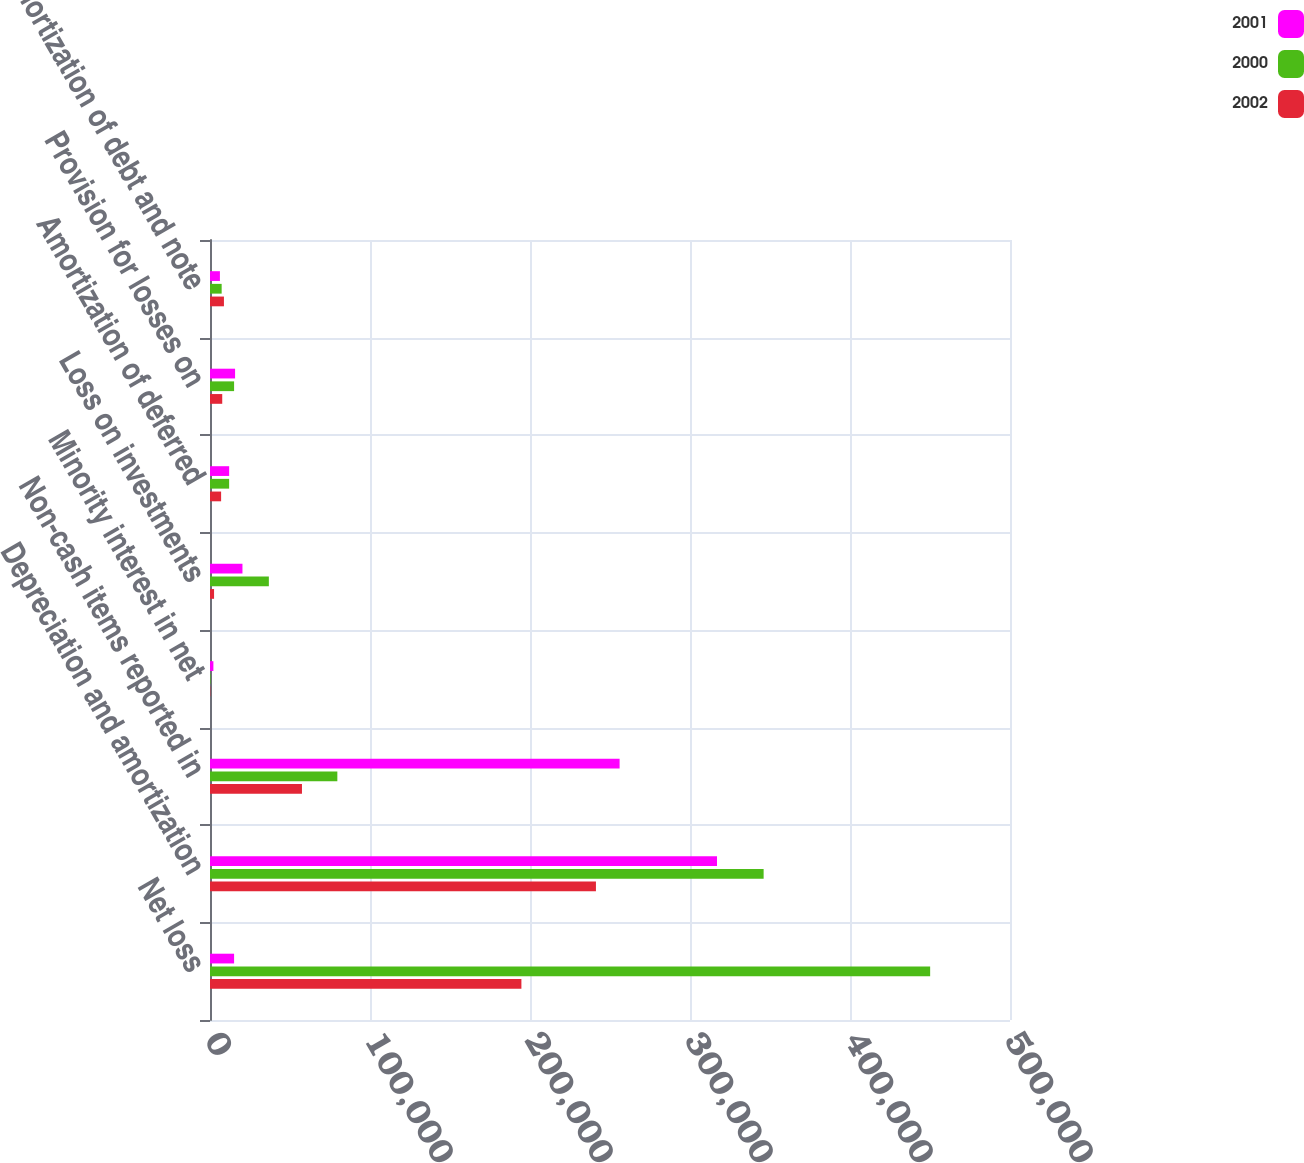Convert chart to OTSL. <chart><loc_0><loc_0><loc_500><loc_500><stacked_bar_chart><ecel><fcel>Net loss<fcel>Depreciation and amortization<fcel>Non-cash items reported in<fcel>Minority interest in net<fcel>Loss on investments<fcel>Amortization of deferred<fcel>Provision for losses on<fcel>Amortization of debt and note<nl><fcel>2001<fcel>15057<fcel>316876<fcel>256005<fcel>2118<fcel>20286<fcel>11972<fcel>15675<fcel>6194<nl><fcel>2000<fcel>450094<fcel>346020<fcel>79585<fcel>318<fcel>36784<fcel>11959<fcel>15057<fcel>7286<nl><fcel>2002<fcel>194628<fcel>241211<fcel>57479<fcel>202<fcel>2538<fcel>6945<fcel>7648<fcel>8712<nl></chart> 